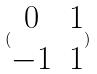Convert formula to latex. <formula><loc_0><loc_0><loc_500><loc_500>( \begin{matrix} 0 & 1 \\ - 1 & 1 \end{matrix} )</formula> 